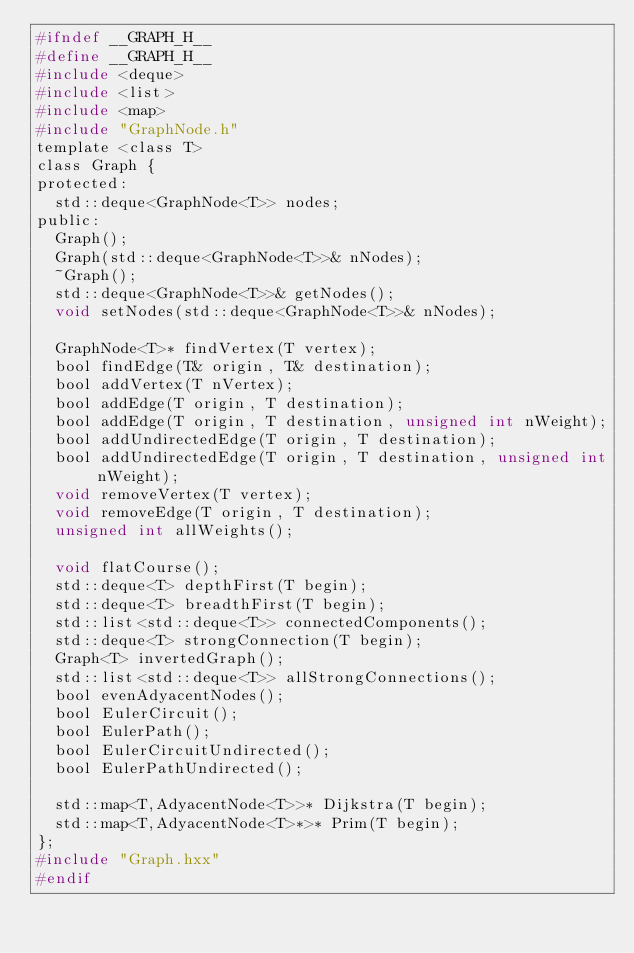<code> <loc_0><loc_0><loc_500><loc_500><_C_>#ifndef __GRAPH_H__
#define __GRAPH_H__
#include <deque>
#include <list>
#include <map>
#include "GraphNode.h"
template <class T>
class Graph {
protected:
  std::deque<GraphNode<T>> nodes;
public:
  Graph();
  Graph(std::deque<GraphNode<T>>& nNodes);
  ~Graph();
  std::deque<GraphNode<T>>& getNodes();
  void setNodes(std::deque<GraphNode<T>>& nNodes);

  GraphNode<T>* findVertex(T vertex);
  bool findEdge(T& origin, T& destination);
  bool addVertex(T nVertex);
  bool addEdge(T origin, T destination);
  bool addEdge(T origin, T destination, unsigned int nWeight);
  bool addUndirectedEdge(T origin, T destination);
  bool addUndirectedEdge(T origin, T destination, unsigned int nWeight);
  void removeVertex(T vertex);
  void removeEdge(T origin, T destination);
  unsigned int allWeights();

  void flatCourse();
  std::deque<T> depthFirst(T begin);
  std::deque<T> breadthFirst(T begin);
  std::list<std::deque<T>> connectedComponents();
  std::deque<T> strongConnection(T begin);
  Graph<T> invertedGraph();
  std::list<std::deque<T>> allStrongConnections();
  bool evenAdyacentNodes();
  bool EulerCircuit();
  bool EulerPath();
  bool EulerCircuitUndirected();
  bool EulerPathUndirected();

  std::map<T,AdyacentNode<T>>* Dijkstra(T begin);
  std::map<T,AdyacentNode<T>*>* Prim(T begin);
};
#include "Graph.hxx"
#endif
</code> 